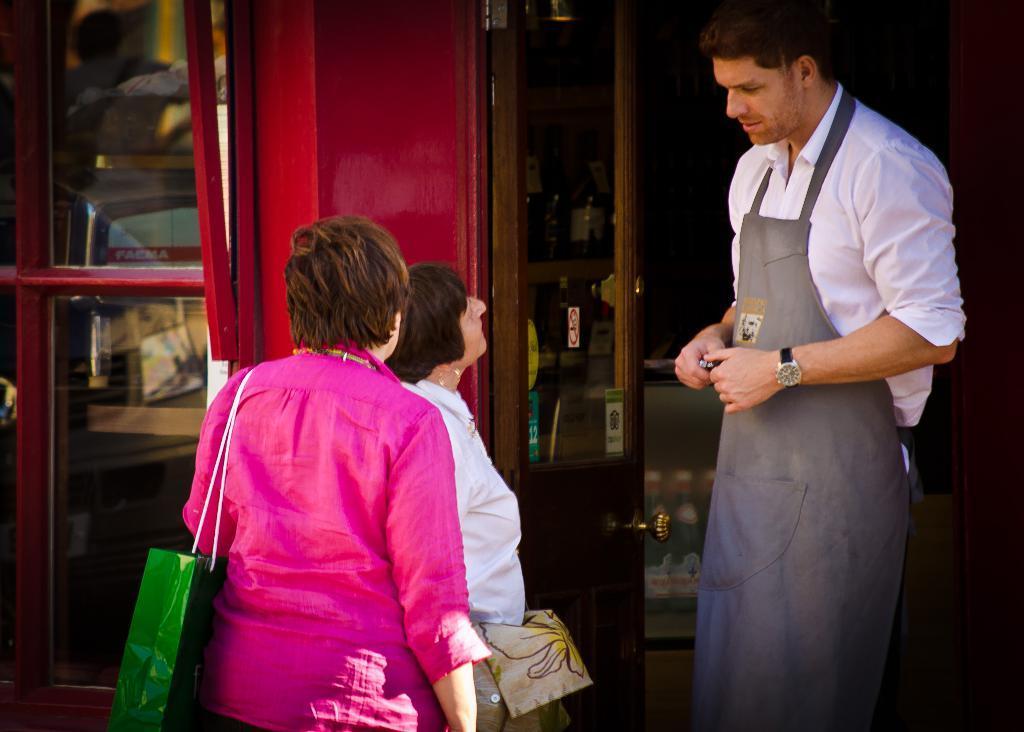Could you give a brief overview of what you see in this image? In this image, we can see some people standing, there is a glass door and we can see the wall. 